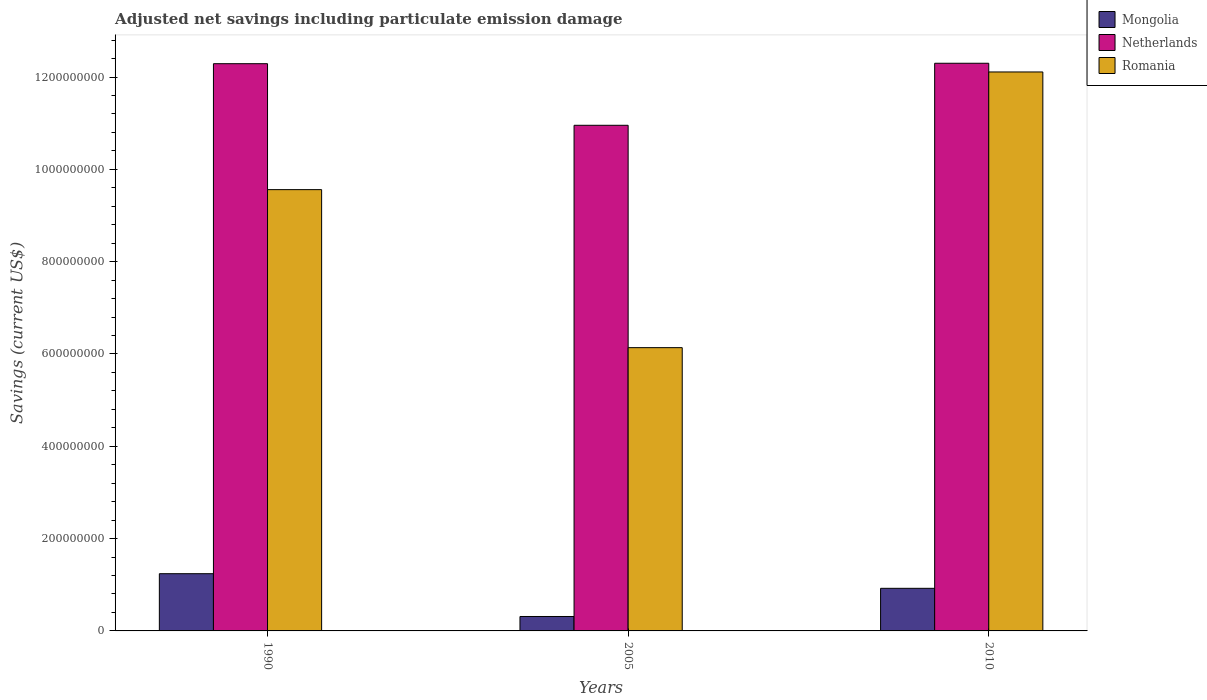How many different coloured bars are there?
Keep it short and to the point. 3. How many groups of bars are there?
Offer a very short reply. 3. Are the number of bars per tick equal to the number of legend labels?
Offer a terse response. Yes. How many bars are there on the 1st tick from the left?
Give a very brief answer. 3. In how many cases, is the number of bars for a given year not equal to the number of legend labels?
Offer a terse response. 0. What is the net savings in Mongolia in 1990?
Offer a very short reply. 1.24e+08. Across all years, what is the maximum net savings in Netherlands?
Your answer should be very brief. 1.23e+09. Across all years, what is the minimum net savings in Romania?
Your response must be concise. 6.14e+08. In which year was the net savings in Netherlands maximum?
Your answer should be very brief. 2010. In which year was the net savings in Romania minimum?
Your response must be concise. 2005. What is the total net savings in Mongolia in the graph?
Your response must be concise. 2.48e+08. What is the difference between the net savings in Romania in 1990 and that in 2005?
Provide a succinct answer. 3.42e+08. What is the difference between the net savings in Mongolia in 2010 and the net savings in Romania in 2005?
Give a very brief answer. -5.21e+08. What is the average net savings in Romania per year?
Make the answer very short. 9.27e+08. In the year 1990, what is the difference between the net savings in Romania and net savings in Mongolia?
Your response must be concise. 8.32e+08. In how many years, is the net savings in Romania greater than 1240000000 US$?
Your answer should be compact. 0. What is the ratio of the net savings in Romania in 1990 to that in 2005?
Provide a succinct answer. 1.56. Is the net savings in Mongolia in 1990 less than that in 2005?
Provide a short and direct response. No. What is the difference between the highest and the second highest net savings in Romania?
Make the answer very short. 2.55e+08. What is the difference between the highest and the lowest net savings in Romania?
Ensure brevity in your answer.  5.97e+08. In how many years, is the net savings in Netherlands greater than the average net savings in Netherlands taken over all years?
Your response must be concise. 2. Is the sum of the net savings in Romania in 1990 and 2005 greater than the maximum net savings in Netherlands across all years?
Keep it short and to the point. Yes. What does the 3rd bar from the left in 1990 represents?
Offer a very short reply. Romania. What does the 3rd bar from the right in 2010 represents?
Offer a very short reply. Mongolia. Is it the case that in every year, the sum of the net savings in Romania and net savings in Mongolia is greater than the net savings in Netherlands?
Make the answer very short. No. Are all the bars in the graph horizontal?
Your answer should be compact. No. Are the values on the major ticks of Y-axis written in scientific E-notation?
Keep it short and to the point. No. Does the graph contain grids?
Your response must be concise. No. Where does the legend appear in the graph?
Your answer should be compact. Top right. What is the title of the graph?
Your answer should be compact. Adjusted net savings including particulate emission damage. What is the label or title of the Y-axis?
Your response must be concise. Savings (current US$). What is the Savings (current US$) in Mongolia in 1990?
Offer a very short reply. 1.24e+08. What is the Savings (current US$) of Netherlands in 1990?
Give a very brief answer. 1.23e+09. What is the Savings (current US$) in Romania in 1990?
Offer a terse response. 9.56e+08. What is the Savings (current US$) in Mongolia in 2005?
Ensure brevity in your answer.  3.13e+07. What is the Savings (current US$) of Netherlands in 2005?
Ensure brevity in your answer.  1.10e+09. What is the Savings (current US$) of Romania in 2005?
Provide a short and direct response. 6.14e+08. What is the Savings (current US$) of Mongolia in 2010?
Make the answer very short. 9.23e+07. What is the Savings (current US$) in Netherlands in 2010?
Your response must be concise. 1.23e+09. What is the Savings (current US$) in Romania in 2010?
Give a very brief answer. 1.21e+09. Across all years, what is the maximum Savings (current US$) in Mongolia?
Make the answer very short. 1.24e+08. Across all years, what is the maximum Savings (current US$) in Netherlands?
Provide a short and direct response. 1.23e+09. Across all years, what is the maximum Savings (current US$) of Romania?
Your answer should be compact. 1.21e+09. Across all years, what is the minimum Savings (current US$) of Mongolia?
Make the answer very short. 3.13e+07. Across all years, what is the minimum Savings (current US$) in Netherlands?
Keep it short and to the point. 1.10e+09. Across all years, what is the minimum Savings (current US$) of Romania?
Offer a terse response. 6.14e+08. What is the total Savings (current US$) of Mongolia in the graph?
Offer a terse response. 2.48e+08. What is the total Savings (current US$) of Netherlands in the graph?
Offer a terse response. 3.55e+09. What is the total Savings (current US$) of Romania in the graph?
Offer a very short reply. 2.78e+09. What is the difference between the Savings (current US$) of Mongolia in 1990 and that in 2005?
Offer a very short reply. 9.27e+07. What is the difference between the Savings (current US$) of Netherlands in 1990 and that in 2005?
Give a very brief answer. 1.33e+08. What is the difference between the Savings (current US$) of Romania in 1990 and that in 2005?
Your answer should be very brief. 3.42e+08. What is the difference between the Savings (current US$) in Mongolia in 1990 and that in 2010?
Ensure brevity in your answer.  3.17e+07. What is the difference between the Savings (current US$) of Netherlands in 1990 and that in 2010?
Provide a succinct answer. -9.44e+05. What is the difference between the Savings (current US$) of Romania in 1990 and that in 2010?
Give a very brief answer. -2.55e+08. What is the difference between the Savings (current US$) of Mongolia in 2005 and that in 2010?
Provide a short and direct response. -6.10e+07. What is the difference between the Savings (current US$) in Netherlands in 2005 and that in 2010?
Provide a succinct answer. -1.34e+08. What is the difference between the Savings (current US$) in Romania in 2005 and that in 2010?
Offer a terse response. -5.97e+08. What is the difference between the Savings (current US$) of Mongolia in 1990 and the Savings (current US$) of Netherlands in 2005?
Your answer should be compact. -9.72e+08. What is the difference between the Savings (current US$) of Mongolia in 1990 and the Savings (current US$) of Romania in 2005?
Offer a terse response. -4.90e+08. What is the difference between the Savings (current US$) of Netherlands in 1990 and the Savings (current US$) of Romania in 2005?
Provide a short and direct response. 6.15e+08. What is the difference between the Savings (current US$) of Mongolia in 1990 and the Savings (current US$) of Netherlands in 2010?
Your response must be concise. -1.11e+09. What is the difference between the Savings (current US$) of Mongolia in 1990 and the Savings (current US$) of Romania in 2010?
Your answer should be very brief. -1.09e+09. What is the difference between the Savings (current US$) of Netherlands in 1990 and the Savings (current US$) of Romania in 2010?
Provide a short and direct response. 1.79e+07. What is the difference between the Savings (current US$) of Mongolia in 2005 and the Savings (current US$) of Netherlands in 2010?
Provide a succinct answer. -1.20e+09. What is the difference between the Savings (current US$) in Mongolia in 2005 and the Savings (current US$) in Romania in 2010?
Your answer should be very brief. -1.18e+09. What is the difference between the Savings (current US$) in Netherlands in 2005 and the Savings (current US$) in Romania in 2010?
Keep it short and to the point. -1.16e+08. What is the average Savings (current US$) of Mongolia per year?
Offer a terse response. 8.25e+07. What is the average Savings (current US$) of Netherlands per year?
Offer a terse response. 1.18e+09. What is the average Savings (current US$) of Romania per year?
Ensure brevity in your answer.  9.27e+08. In the year 1990, what is the difference between the Savings (current US$) in Mongolia and Savings (current US$) in Netherlands?
Ensure brevity in your answer.  -1.10e+09. In the year 1990, what is the difference between the Savings (current US$) of Mongolia and Savings (current US$) of Romania?
Provide a succinct answer. -8.32e+08. In the year 1990, what is the difference between the Savings (current US$) of Netherlands and Savings (current US$) of Romania?
Provide a short and direct response. 2.73e+08. In the year 2005, what is the difference between the Savings (current US$) in Mongolia and Savings (current US$) in Netherlands?
Keep it short and to the point. -1.06e+09. In the year 2005, what is the difference between the Savings (current US$) in Mongolia and Savings (current US$) in Romania?
Offer a terse response. -5.82e+08. In the year 2005, what is the difference between the Savings (current US$) in Netherlands and Savings (current US$) in Romania?
Offer a terse response. 4.82e+08. In the year 2010, what is the difference between the Savings (current US$) of Mongolia and Savings (current US$) of Netherlands?
Your response must be concise. -1.14e+09. In the year 2010, what is the difference between the Savings (current US$) of Mongolia and Savings (current US$) of Romania?
Provide a short and direct response. -1.12e+09. In the year 2010, what is the difference between the Savings (current US$) of Netherlands and Savings (current US$) of Romania?
Offer a very short reply. 1.89e+07. What is the ratio of the Savings (current US$) of Mongolia in 1990 to that in 2005?
Offer a terse response. 3.96. What is the ratio of the Savings (current US$) in Netherlands in 1990 to that in 2005?
Offer a very short reply. 1.12. What is the ratio of the Savings (current US$) in Romania in 1990 to that in 2005?
Provide a succinct answer. 1.56. What is the ratio of the Savings (current US$) of Mongolia in 1990 to that in 2010?
Your answer should be very brief. 1.34. What is the ratio of the Savings (current US$) in Romania in 1990 to that in 2010?
Your answer should be compact. 0.79. What is the ratio of the Savings (current US$) of Mongolia in 2005 to that in 2010?
Ensure brevity in your answer.  0.34. What is the ratio of the Savings (current US$) in Netherlands in 2005 to that in 2010?
Make the answer very short. 0.89. What is the ratio of the Savings (current US$) in Romania in 2005 to that in 2010?
Offer a terse response. 0.51. What is the difference between the highest and the second highest Savings (current US$) of Mongolia?
Keep it short and to the point. 3.17e+07. What is the difference between the highest and the second highest Savings (current US$) of Netherlands?
Give a very brief answer. 9.44e+05. What is the difference between the highest and the second highest Savings (current US$) in Romania?
Make the answer very short. 2.55e+08. What is the difference between the highest and the lowest Savings (current US$) of Mongolia?
Ensure brevity in your answer.  9.27e+07. What is the difference between the highest and the lowest Savings (current US$) in Netherlands?
Provide a succinct answer. 1.34e+08. What is the difference between the highest and the lowest Savings (current US$) of Romania?
Offer a terse response. 5.97e+08. 